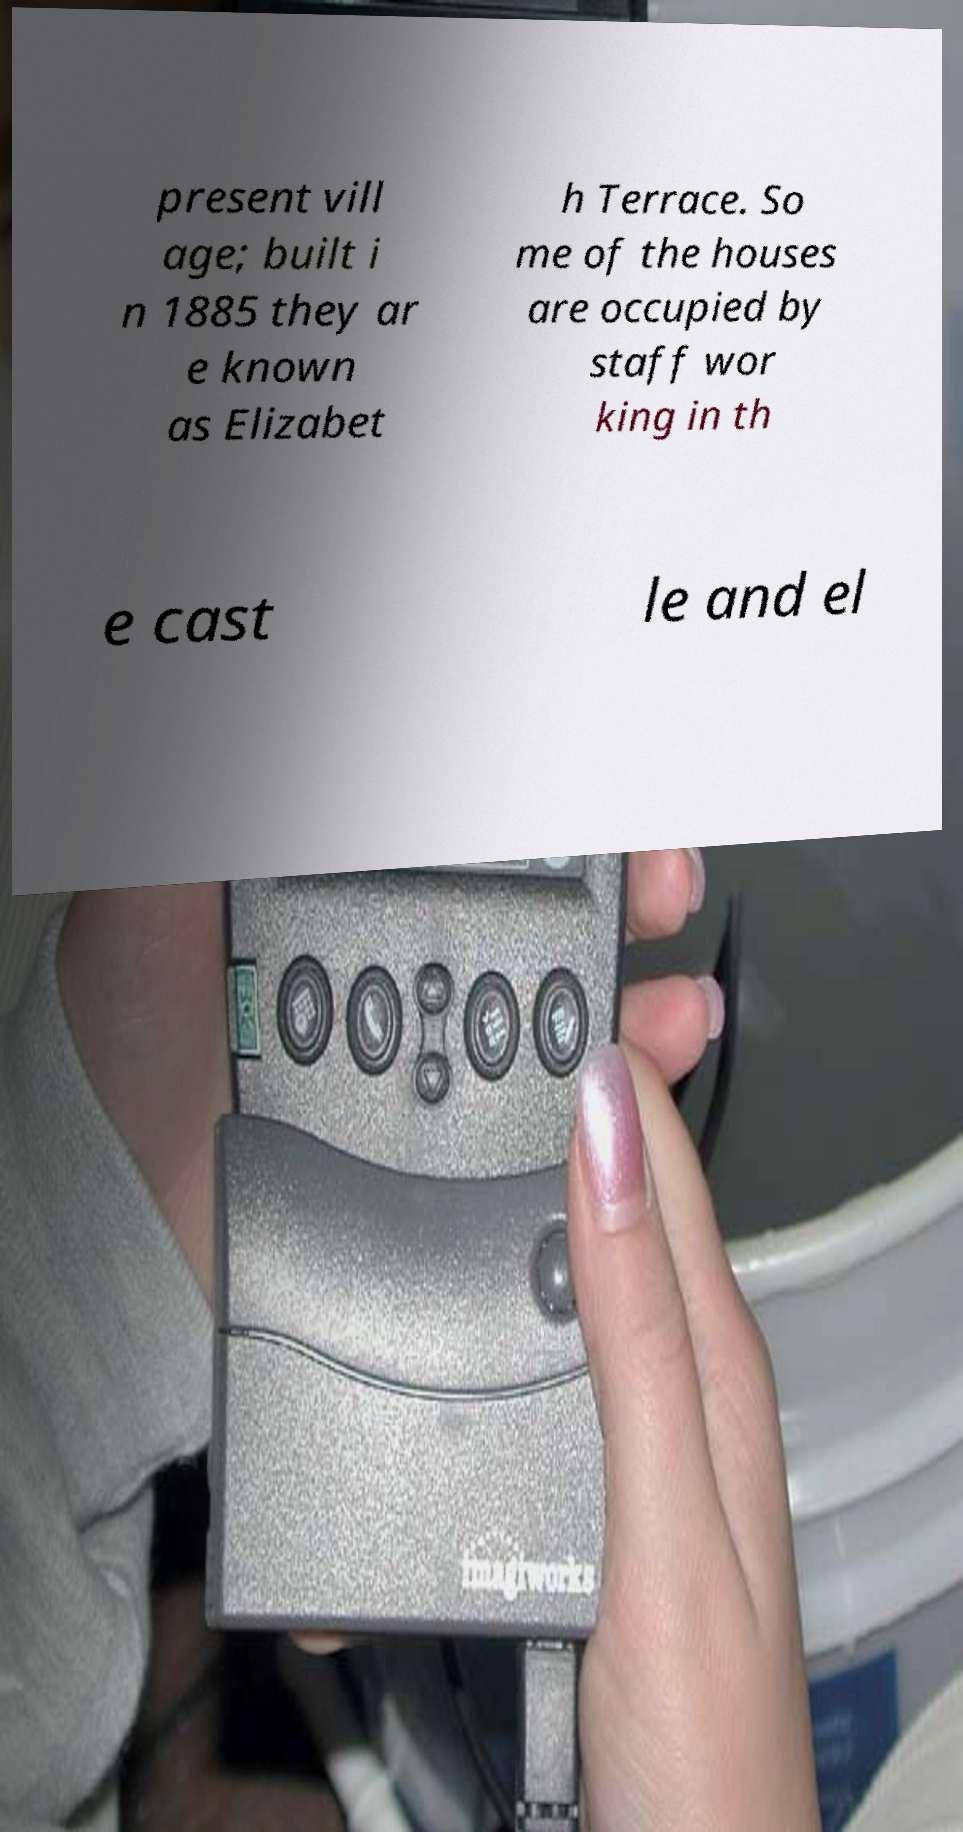Could you assist in decoding the text presented in this image and type it out clearly? present vill age; built i n 1885 they ar e known as Elizabet h Terrace. So me of the houses are occupied by staff wor king in th e cast le and el 